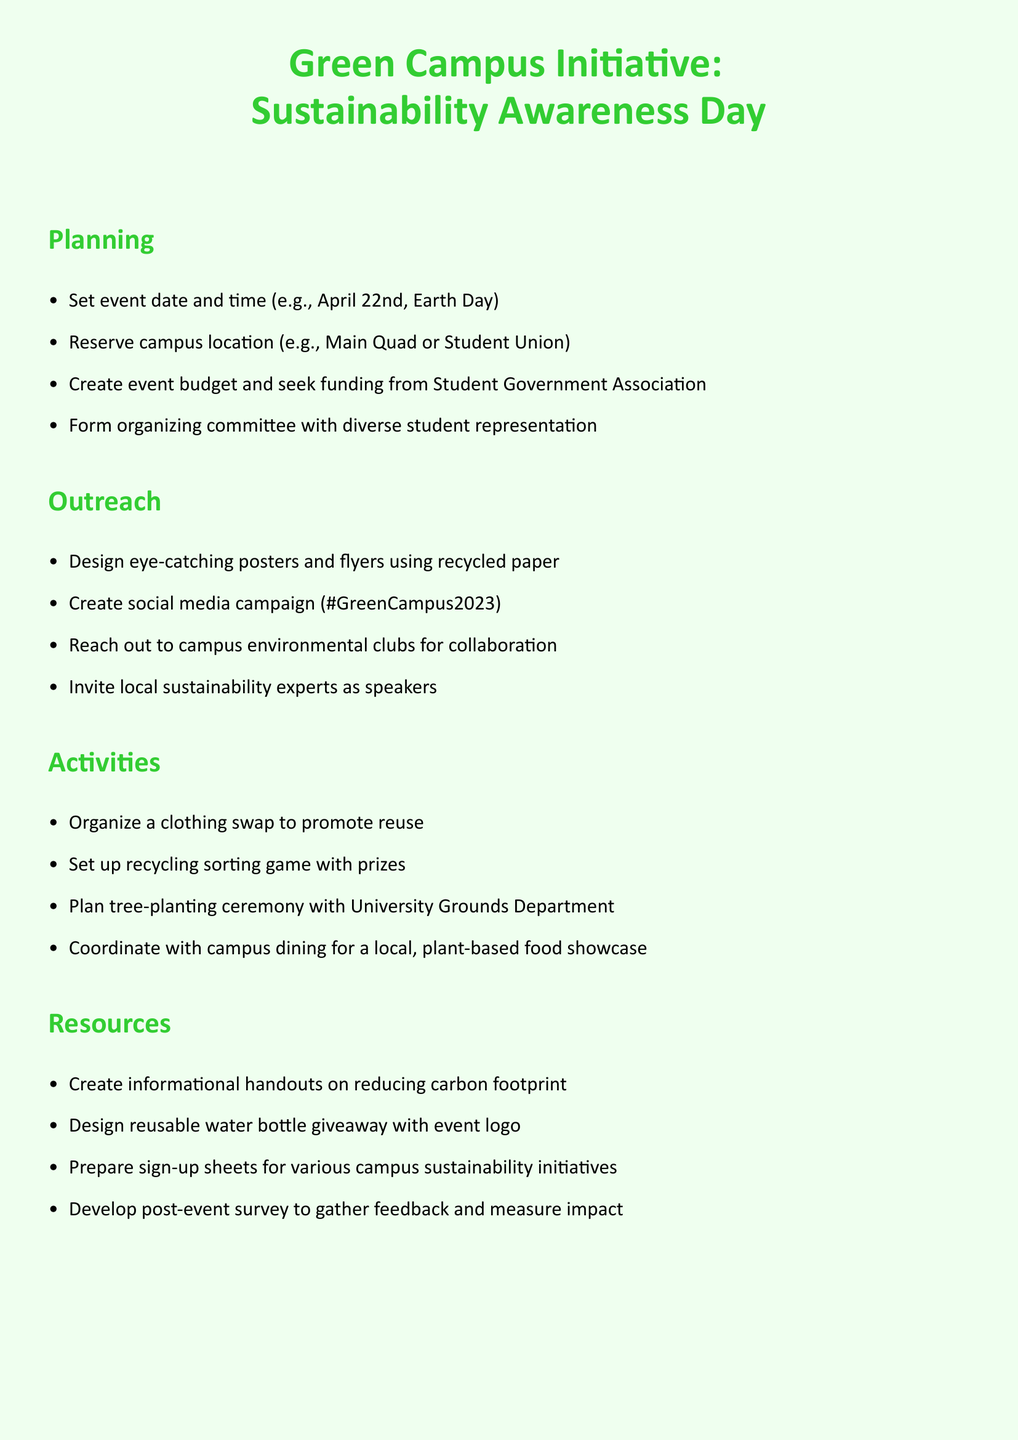what is the event date? The document mentions that the event date is set for April 22nd, which is Earth Day.
Answer: April 22nd who is responsible for reserving the campus location? The task states to reserve the location, which implies an organizer is responsible, typically the organizing committee.
Answer: Organizing committee what hashtag is used for the social media campaign? The document specifies the hashtag created for the social media campaign as #GreenCampus2023.
Answer: #GreenCampus2023 how many sections are in the to-do list? The to-do list is divided into five distinct sections: Planning, Outreach, Activities, Resources, and Logistics.
Answer: Five what type of event supplies will be arranged? The document mentions arranging eco-friendly event supplies such as compostable utensils.
Answer: Eco-friendly event supplies what is one activity planned for the event? The to-do list includes organizing a clothing swap to promote reuse as one of the activities.
Answer: Clothing swap who will be invited as speakers? The document states that local sustainability experts will be invited as speakers for the event.
Answer: Local sustainability experts what will be created to gather feedback after the event? A post-event survey is mentioned for gathering feedback and measuring impact.
Answer: Post-event survey 